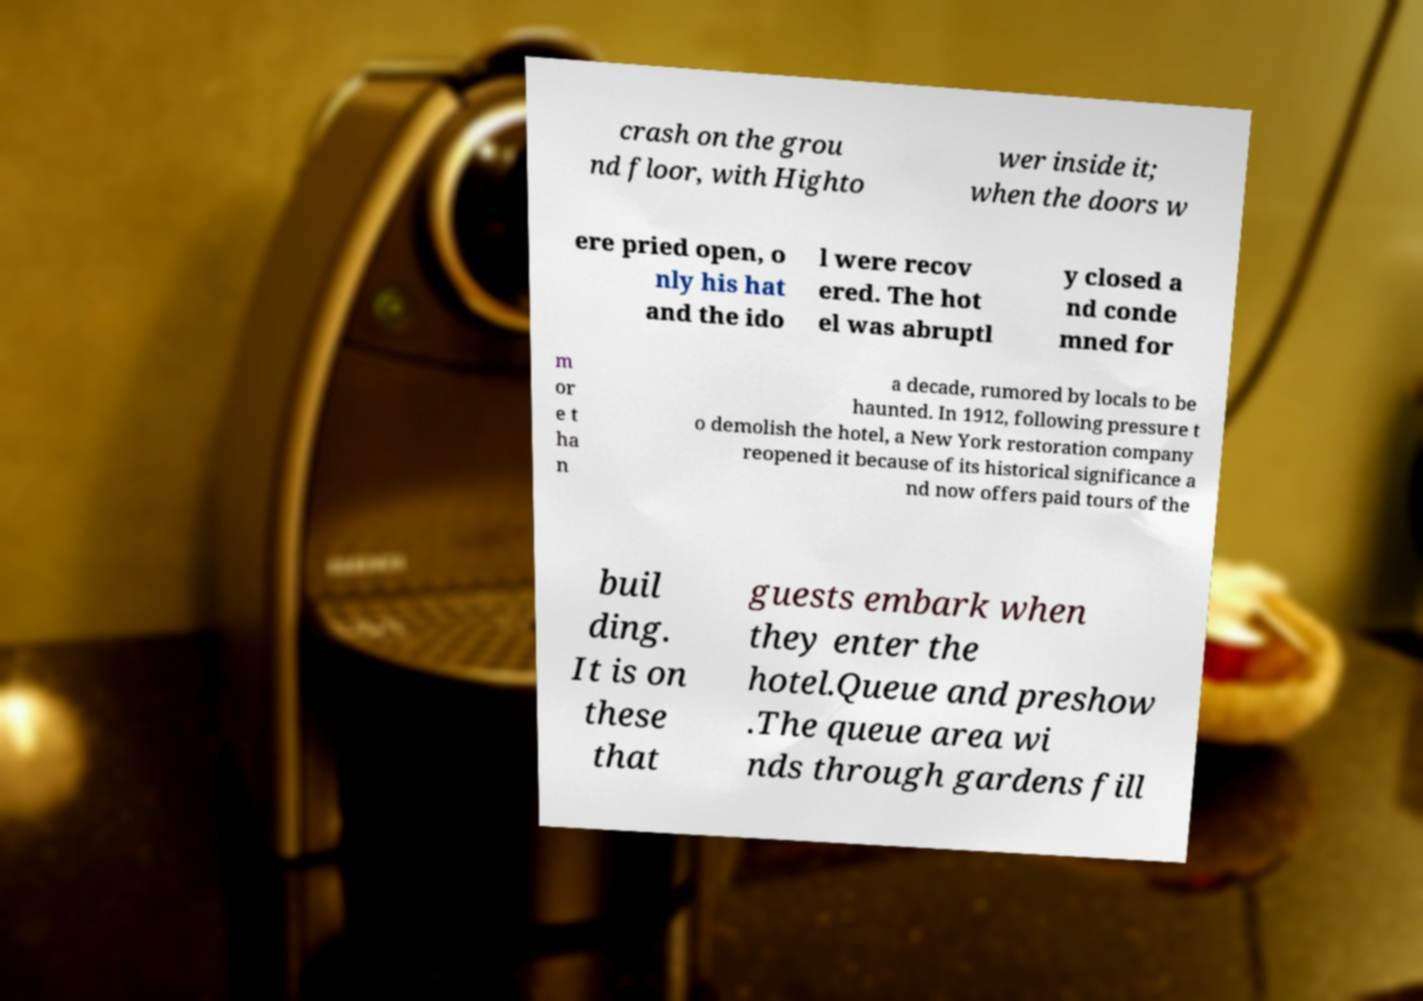Can you accurately transcribe the text from the provided image for me? crash on the grou nd floor, with Highto wer inside it; when the doors w ere pried open, o nly his hat and the ido l were recov ered. The hot el was abruptl y closed a nd conde mned for m or e t ha n a decade, rumored by locals to be haunted. In 1912, following pressure t o demolish the hotel, a New York restoration company reopened it because of its historical significance a nd now offers paid tours of the buil ding. It is on these that guests embark when they enter the hotel.Queue and preshow .The queue area wi nds through gardens fill 